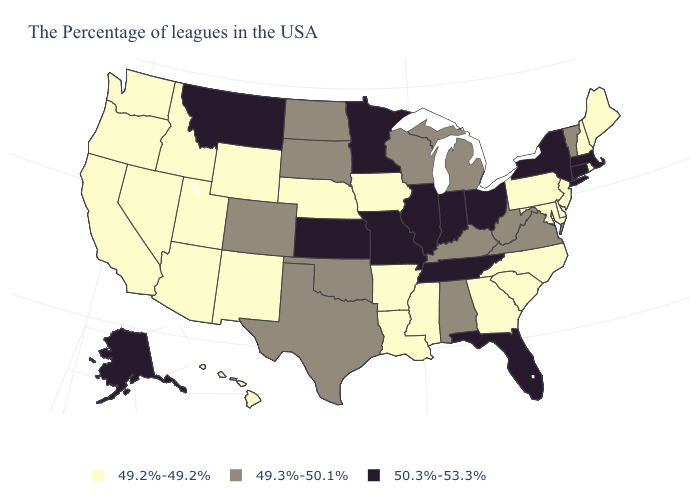Does Virginia have a lower value than West Virginia?
Be succinct. No. Name the states that have a value in the range 49.2%-49.2%?
Give a very brief answer. Maine, Rhode Island, New Hampshire, New Jersey, Delaware, Maryland, Pennsylvania, North Carolina, South Carolina, Georgia, Mississippi, Louisiana, Arkansas, Iowa, Nebraska, Wyoming, New Mexico, Utah, Arizona, Idaho, Nevada, California, Washington, Oregon, Hawaii. Among the states that border New Mexico , does Arizona have the lowest value?
Quick response, please. Yes. What is the value of Washington?
Keep it brief. 49.2%-49.2%. Does Connecticut have the lowest value in the Northeast?
Keep it brief. No. What is the value of Vermont?
Keep it brief. 49.3%-50.1%. Among the states that border Kansas , does Colorado have the highest value?
Be succinct. No. Name the states that have a value in the range 50.3%-53.3%?
Give a very brief answer. Massachusetts, Connecticut, New York, Ohio, Florida, Indiana, Tennessee, Illinois, Missouri, Minnesota, Kansas, Montana, Alaska. What is the lowest value in states that border Vermont?
Quick response, please. 49.2%-49.2%. Among the states that border Connecticut , which have the lowest value?
Short answer required. Rhode Island. How many symbols are there in the legend?
Give a very brief answer. 3. Among the states that border California , which have the highest value?
Give a very brief answer. Arizona, Nevada, Oregon. Which states have the highest value in the USA?
Quick response, please. Massachusetts, Connecticut, New York, Ohio, Florida, Indiana, Tennessee, Illinois, Missouri, Minnesota, Kansas, Montana, Alaska. 